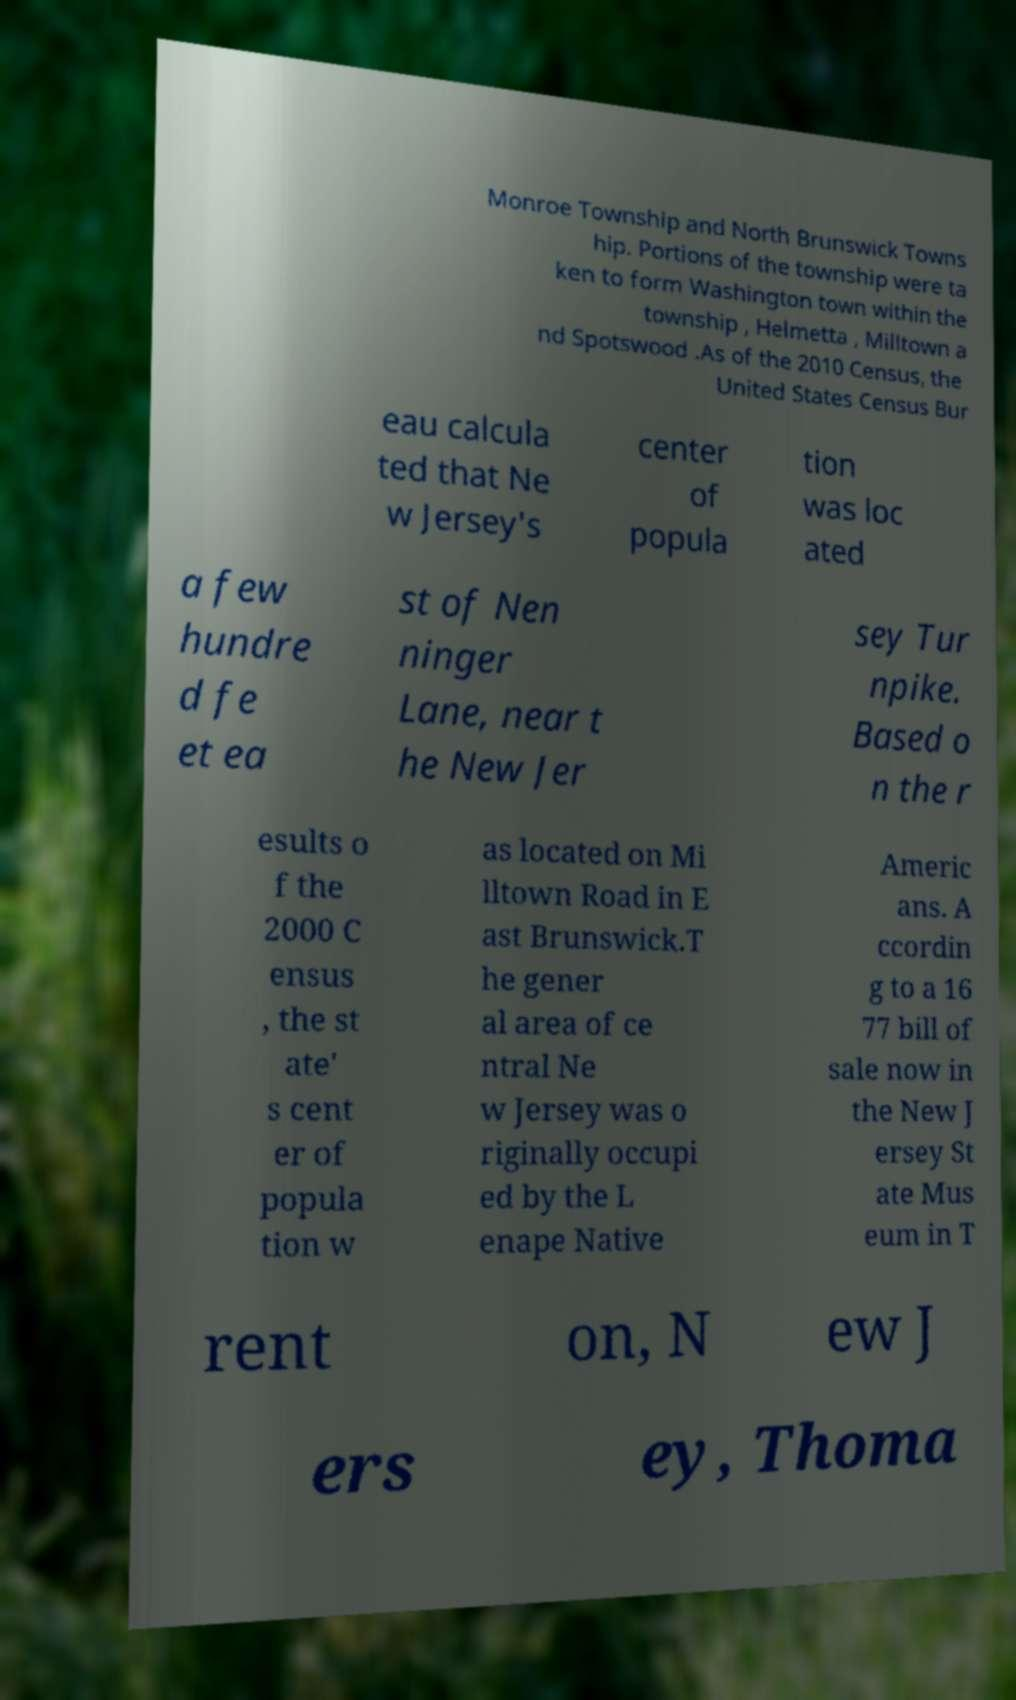What messages or text are displayed in this image? I need them in a readable, typed format. Monroe Township and North Brunswick Towns hip. Portions of the township were ta ken to form Washington town within the township , Helmetta , Milltown a nd Spotswood .As of the 2010 Census, the United States Census Bur eau calcula ted that Ne w Jersey's center of popula tion was loc ated a few hundre d fe et ea st of Nen ninger Lane, near t he New Jer sey Tur npike. Based o n the r esults o f the 2000 C ensus , the st ate' s cent er of popula tion w as located on Mi lltown Road in E ast Brunswick.T he gener al area of ce ntral Ne w Jersey was o riginally occupi ed by the L enape Native Americ ans. A ccordin g to a 16 77 bill of sale now in the New J ersey St ate Mus eum in T rent on, N ew J ers ey, Thoma 